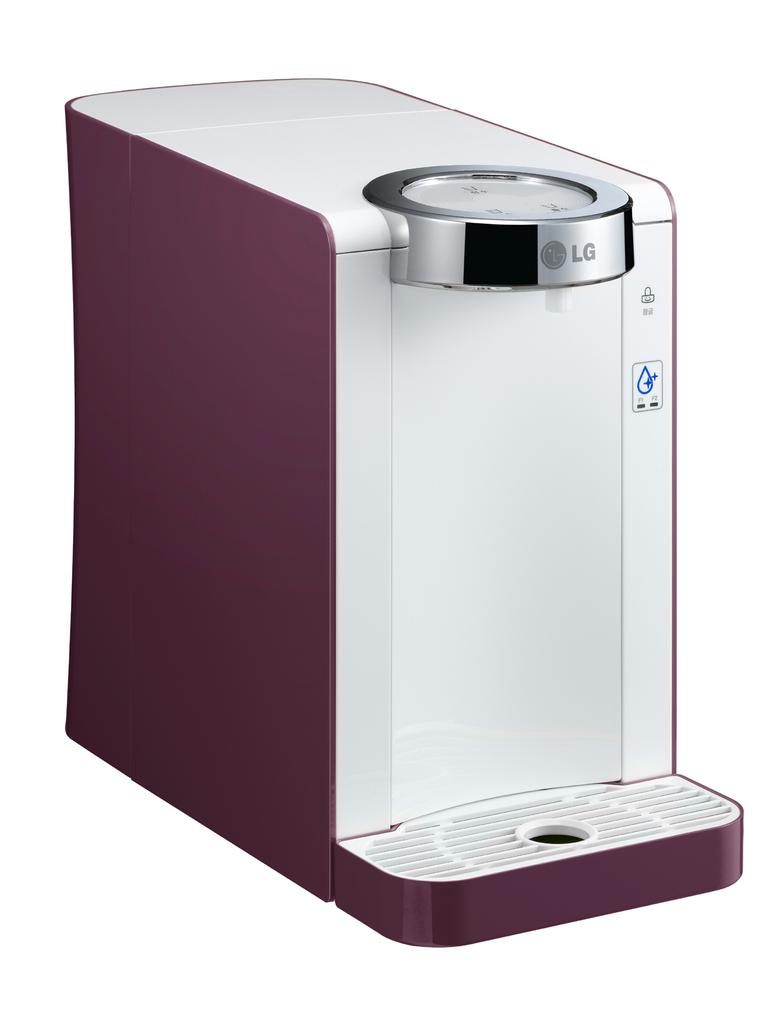What brand is the appliance?
Make the answer very short. Lg. 